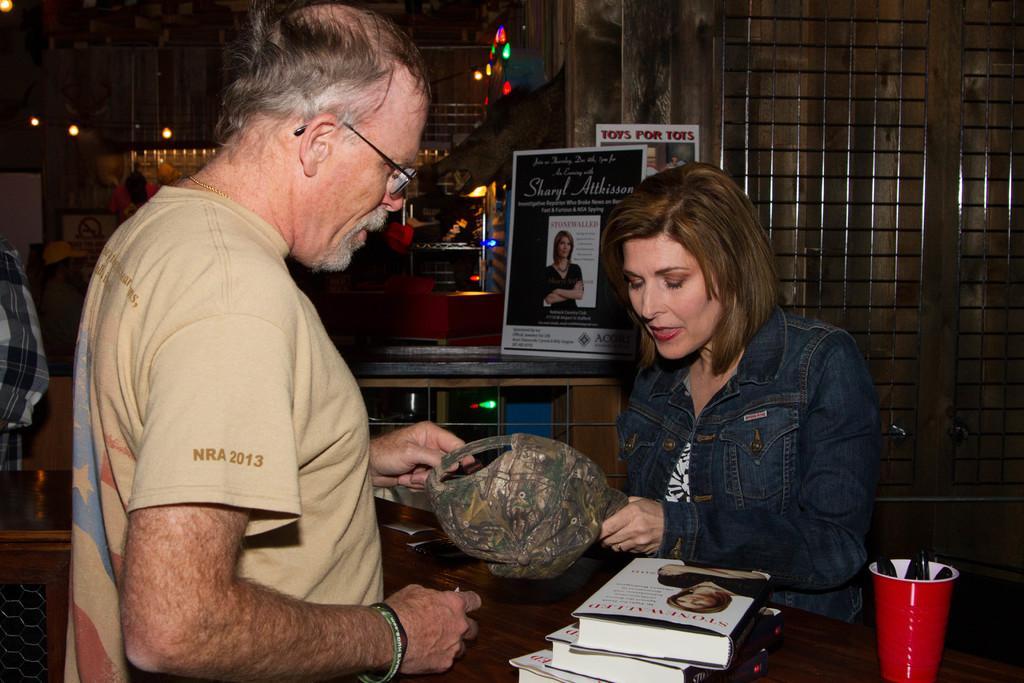In one or two sentences, can you explain what this image depicts? There is a person standing in the left corner and there is a woman standing in front of him holding a cap in her hand and there is a table in between them which has books and some other objects on it. 